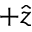Convert formula to latex. <formula><loc_0><loc_0><loc_500><loc_500>+ \hat { z }</formula> 